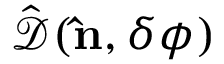<formula> <loc_0><loc_0><loc_500><loc_500>\hat { \mathcal { D } } ( { \hat { n } } , \delta \phi )</formula> 